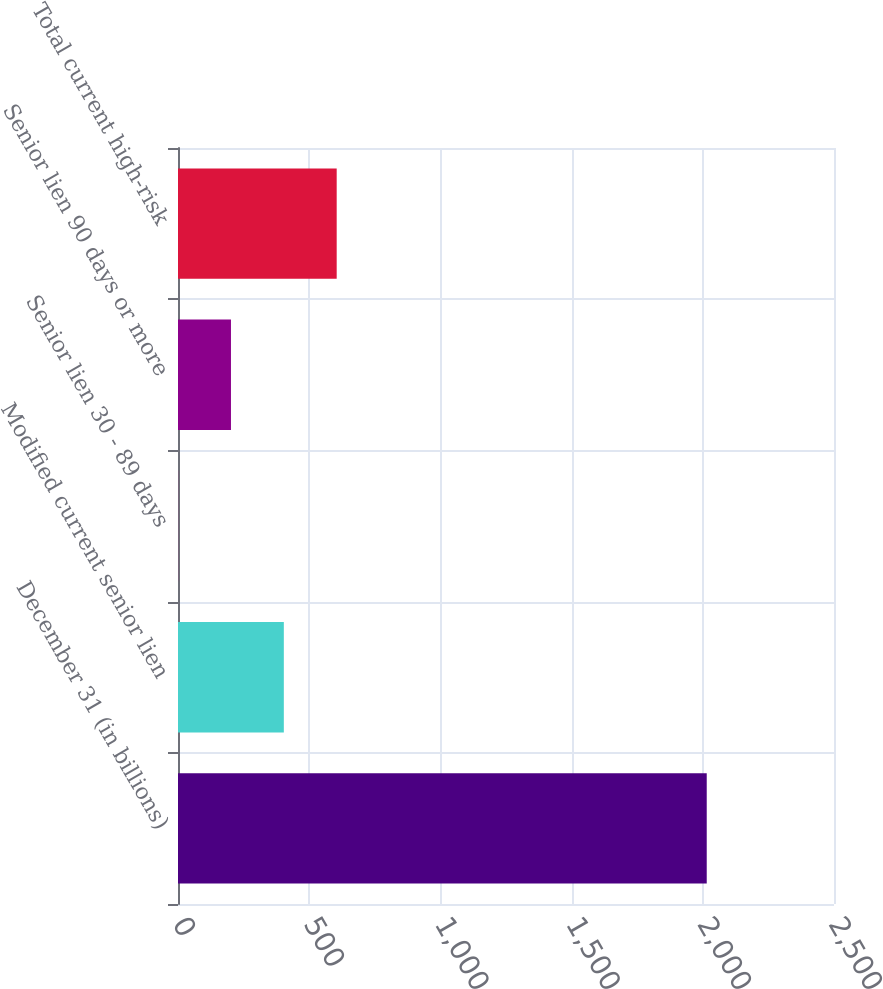Convert chart. <chart><loc_0><loc_0><loc_500><loc_500><bar_chart><fcel>December 31 (in billions)<fcel>Modified current senior lien<fcel>Senior lien 30 - 89 days<fcel>Senior lien 90 days or more<fcel>Total current high-risk<nl><fcel>2015<fcel>403.32<fcel>0.4<fcel>201.86<fcel>604.78<nl></chart> 